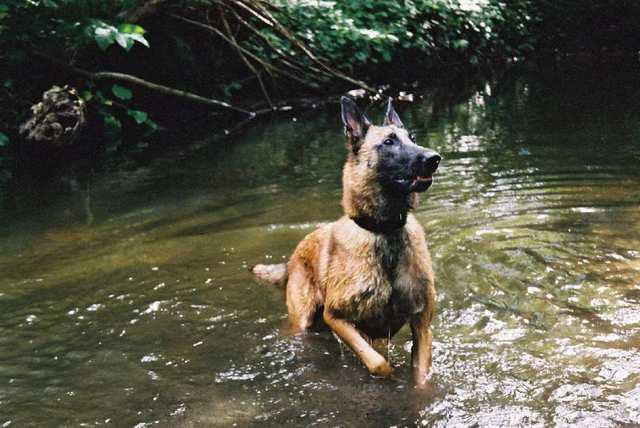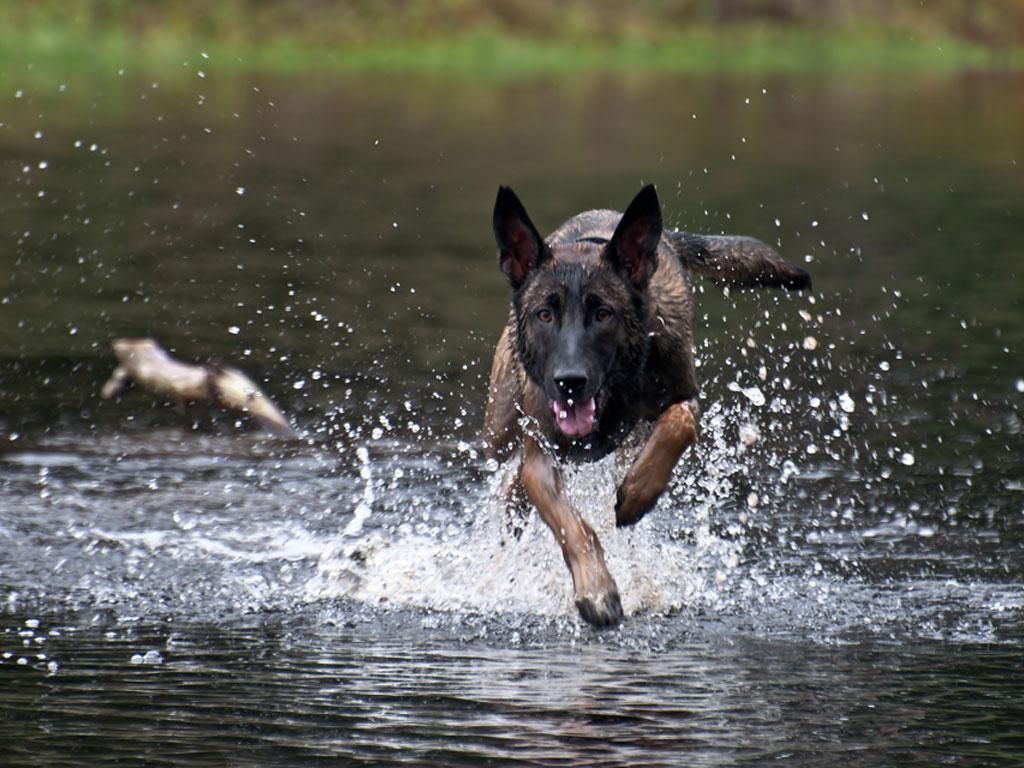The first image is the image on the left, the second image is the image on the right. Assess this claim about the two images: "An image shows a dog running toward the camera and facing forward.". Correct or not? Answer yes or no. Yes. The first image is the image on the left, the second image is the image on the right. For the images shown, is this caption "At least one dog is running toward the camera." true? Answer yes or no. Yes. 